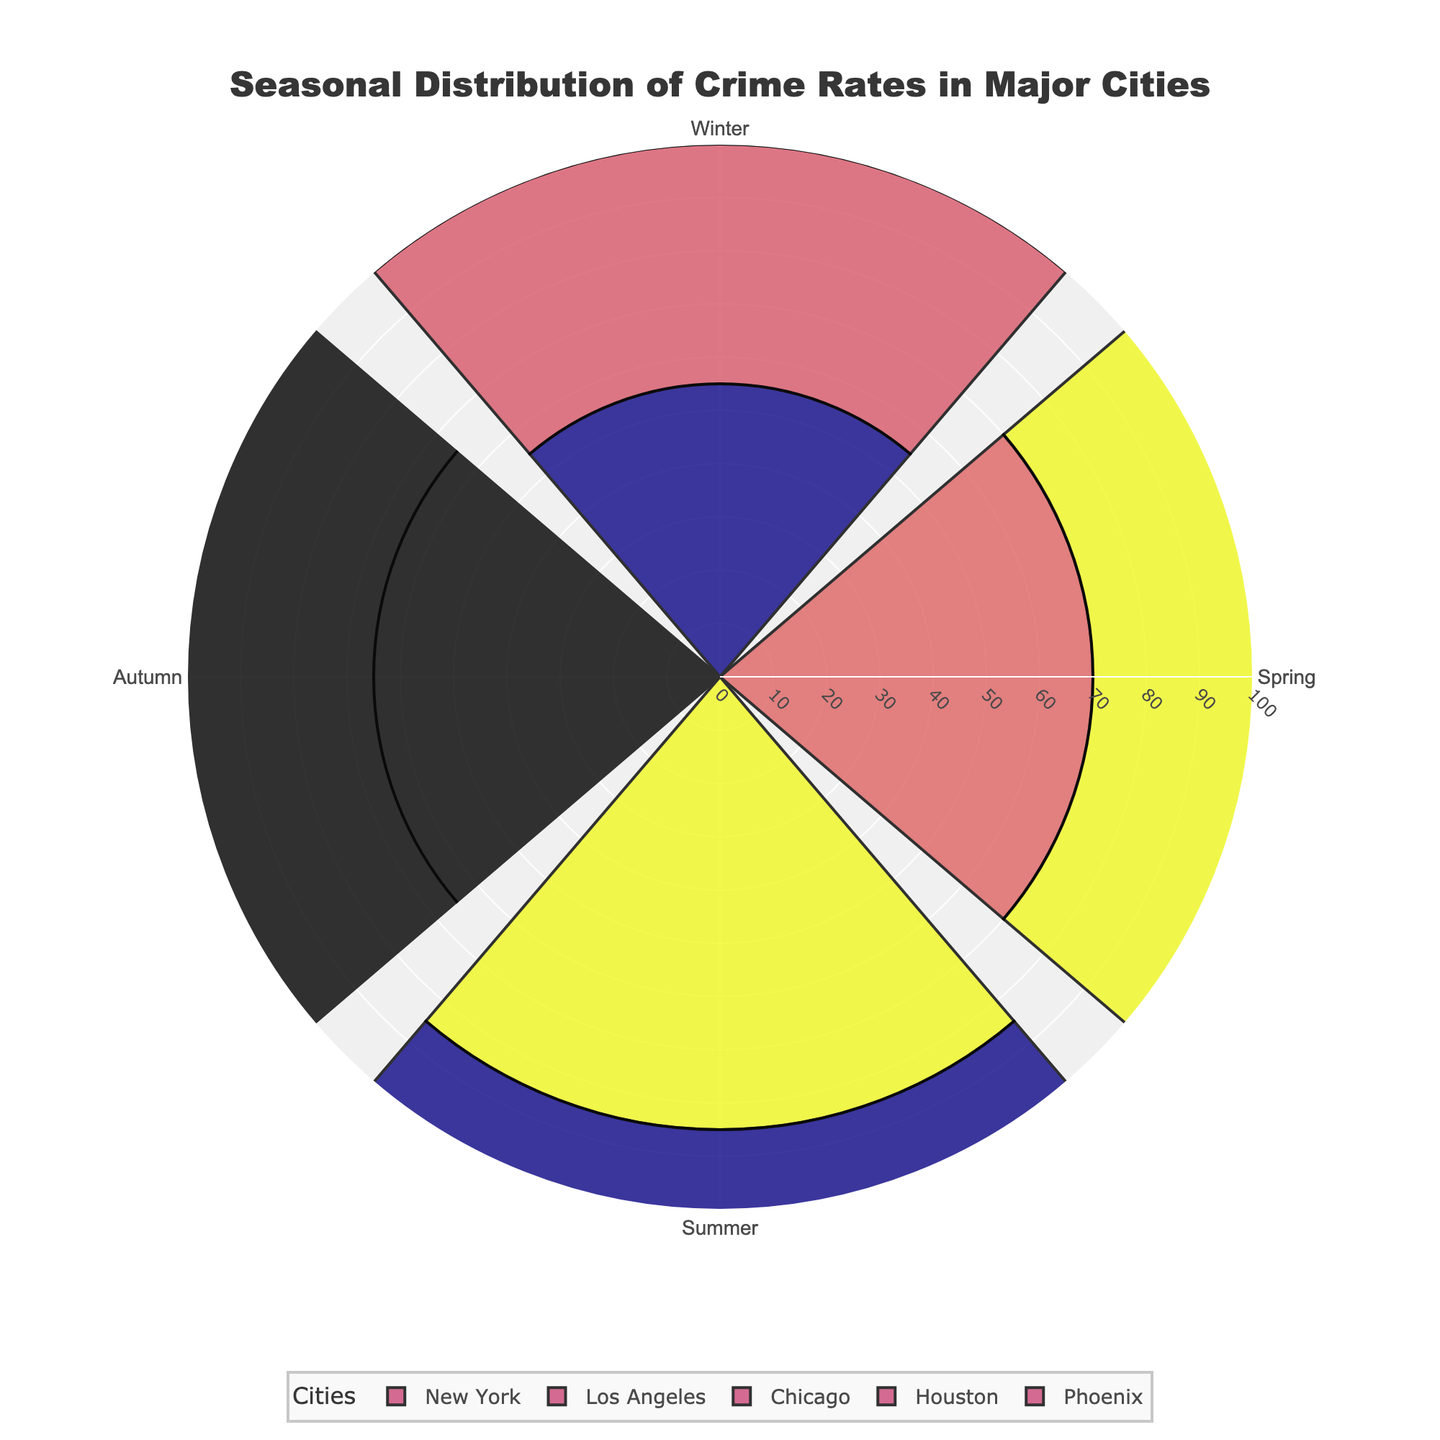What's the title of the chart? The title is usually located at the top center of the chart. By observing the topmost part of the chart, you can easily see the title "Seasonal Distribution of Crime Rates in Major Cities".
Answer: Seasonal Distribution of Crime Rates in Major Cities How many cities are included in the chart? Each city has its section with colored wedges. By listing these, you see New York, Los Angeles, Chicago, Houston, and Phoenix, making a total of 5 cities.
Answer: 5 In which city does Summer have the highest crime rate? Find the wedge representing Summer in each city's section. New York's Summer wedge has the highest value of 85 compared to other cities.
Answer: New York Which season has the lowest crime rate in Phoenix? Look at the different seasonal wedges for Phoenix. Winter has the lowest value at 35.
Answer: Winter Compare the Autumn crime rates for New York and Chicago. Which is higher? Identify the Autumn wedges for New York (65) and Chicago (60). New York's is higher.
Answer: New York What's the total crime rate for Houston in all seasons combined? Add Houston's crime rates for all seasons: 40 (Winter) + 55 (Spring) + 73 (Summer) + 50 (Autumn) = 218
Answer: 218 Is there any season where Chicago and Los Angeles have the same crime rate? Compare the wedges for Chicago and Los Angeles across all seasons. None of the wedges match exactly in value.
Answer: No Which city shows the most significant seasonal variation in crime rates? Determine the range for each city by subtracting the lowest from the highest value: New York (85-55=30), Los Angeles (78-45=33), Chicago (80-50=30), Houston (73-40=33), Phoenix (68-35=33). Los Angeles, Houston, and Phoenix show the highest variation at 33 each.
Answer: Los Angeles, Houston, Phoenix What is the average crime rate in Spring across all cities? Add the Spring rates for all cities (70 + 60 + 65 + 55 + 50) = 300, and divide by the number of cities (5). 300/5 = 60.
Answer: 60 